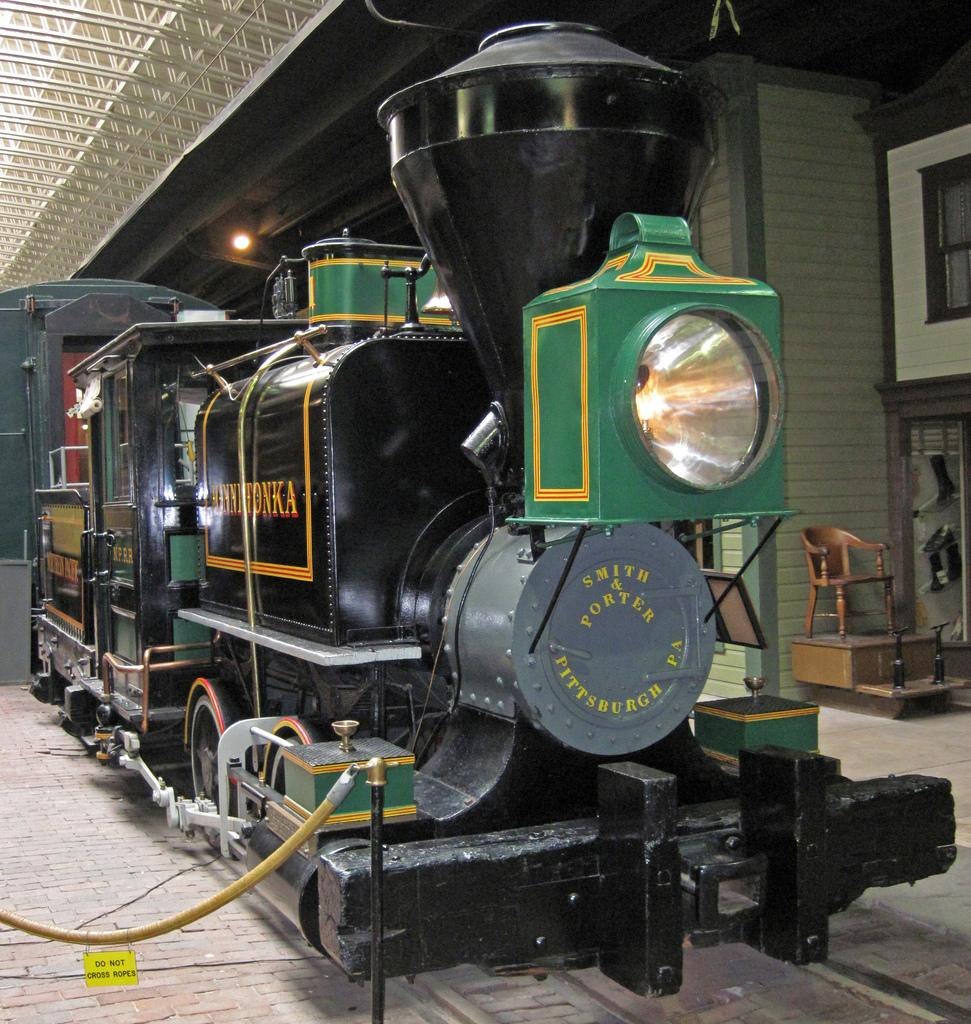What is the main subject of the image? The main subject of the image is a train. Can you describe the color of the train? The train is green and black in color. What can be seen in the background of the image? In the background of the image, there is a wall, a chair, a roof, a light, a cupboard, and other objects. How many snails are crawling on the train in the image? There are no snails present in the image; it features a train and various objects in the background. What are the babies doing in the image? There are no babies present in the image. 